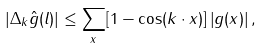Convert formula to latex. <formula><loc_0><loc_0><loc_500><loc_500>\left | \Delta _ { k } \hat { g } ( l ) \right | \leq \sum _ { x } [ 1 - \cos ( k \cdot x ) ] \left | g ( x ) \right | ,</formula> 